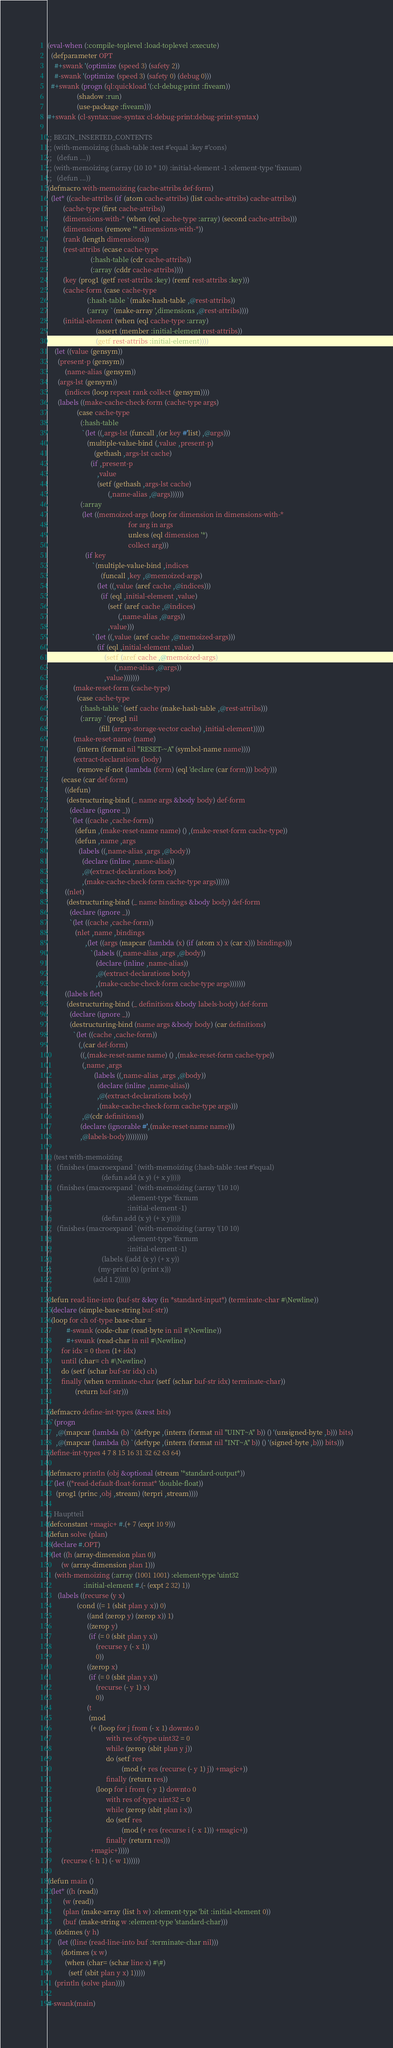<code> <loc_0><loc_0><loc_500><loc_500><_Lisp_>(eval-when (:compile-toplevel :load-toplevel :execute)
  (defparameter OPT
    #+swank '(optimize (speed 3) (safety 2))
    #-swank '(optimize (speed 3) (safety 0) (debug 0)))
  #+swank (progn (ql:quickload '(:cl-debug-print :fiveam))
                 (shadow :run)
                 (use-package :fiveam)))
#+swank (cl-syntax:use-syntax cl-debug-print:debug-print-syntax)

;; BEGIN_INSERTED_CONTENTS
;; (with-memoizing (:hash-table :test #'equal :key #'cons)
;;   (defun ...))
;; (with-memoizing (:array (10 10 * 10) :initial-element -1 :element-type 'fixnum)
;;   (defun ...))
(defmacro with-memoizing (cache-attribs def-form)
  (let* ((cache-attribs (if (atom cache-attribs) (list cache-attribs) cache-attribs))
         (cache-type (first cache-attribs))
         (dimensions-with-* (when (eql cache-type :array) (second cache-attribs)))
         (dimensions (remove '* dimensions-with-*))
         (rank (length dimensions))
         (rest-attribs (ecase cache-type
                         (:hash-table (cdr cache-attribs))
                         (:array (cddr cache-attribs))))
         (key (prog1 (getf rest-attribs :key) (remf rest-attribs :key)))
         (cache-form (case cache-type
                       (:hash-table `(make-hash-table ,@rest-attribs))
                       (:array `(make-array ',dimensions ,@rest-attribs))))
         (initial-element (when (eql cache-type :array)
                            (assert (member :initial-element rest-attribs))
                            (getf rest-attribs :initial-element))))
    (let ((value (gensym))
	  (present-p (gensym))
          (name-alias (gensym))
	  (args-lst (gensym))
          (indices (loop repeat rank collect (gensym))))
      (labels ((make-cache-check-form (cache-type args)
                 (case cache-type
                   (:hash-table
                    `(let ((,args-lst (funcall ,(or key #'list) ,@args)))
                       (multiple-value-bind (,value ,present-p)
                           (gethash ,args-lst cache)
                         (if ,present-p
                             ,value
                             (setf (gethash ,args-lst cache)
                                   (,name-alias ,@args))))))
                   (:array
                    (let ((memoized-args (loop for dimension in dimensions-with-*
                                               for arg in args
                                               unless (eql dimension '*)
                                               collect arg)))
                      (if key
                          `(multiple-value-bind ,indices
                               (funcall ,key ,@memoized-args)
                             (let ((,value (aref cache ,@indices)))
                               (if (eql ,initial-element ,value)
                                   (setf (aref cache ,@indices)
                                         (,name-alias ,@args))
                                   ,value)))
                          `(let ((,value (aref cache ,@memoized-args)))
                             (if (eql ,initial-element ,value)
                                 (setf (aref cache ,@memoized-args)
                                       (,name-alias ,@args))
                                 ,value)))))))
               (make-reset-form (cache-type)
                 (case cache-type
                   (:hash-table `(setf cache (make-hash-table ,@rest-attribs)))
                   (:array `(prog1 nil
                              (fill (array-storage-vector cache) ,initial-element)))))
               (make-reset-name (name)
                 (intern (format nil "RESET-~A" (symbol-name name))))
               (extract-declarations (body)
                 (remove-if-not (lambda (form) (eql 'declare (car form))) body)))
        (ecase (car def-form)
          ((defun)
           (destructuring-bind (_ name args &body body) def-form
             (declare (ignore _))
             `(let ((cache ,cache-form))
                (defun ,(make-reset-name name) () ,(make-reset-form cache-type))
                (defun ,name ,args
                  (labels ((,name-alias ,args ,@body))
                    (declare (inline ,name-alias))
                    ,@(extract-declarations body)
                    ,(make-cache-check-form cache-type args))))))
          ((nlet)
           (destructuring-bind (_ name bindings &body body) def-form
             (declare (ignore _))
             `(let ((cache ,cache-form))
                (nlet ,name ,bindings
                      ,(let ((args (mapcar (lambda (x) (if (atom x) x (car x))) bindings)))
                         `(labels ((,name-alias ,args ,@body))
                            (declare (inline ,name-alias))
                            ,@(extract-declarations body)
                            ,(make-cache-check-form cache-type args)))))))
          ((labels flet)
           (destructuring-bind (_ definitions &body labels-body) def-form
             (declare (ignore _))
             (destructuring-bind (name args &body body) (car definitions)
               `(let ((cache ,cache-form))
                  (,(car def-form)
                   ((,(make-reset-name name) () ,(make-reset-form cache-type))
                    (,name ,args
                           (labels ((,name-alias ,args ,@body))
                             (declare (inline ,name-alias))
                             ,@(extract-declarations body)
                             ,(make-cache-check-form cache-type args)))
                    ,@(cdr definitions))
                   (declare (ignorable #',(make-reset-name name)))
                   ,@labels-body))))))))))

;; (test with-memoizing
;;   (finishes (macroexpand `(with-memoizing (:hash-table :test #'equal)
;;                             (defun add (x y) (+ x y)))))
;;   (finishes (macroexpand `(with-memoizing (:array '(10 10)
;;                                            :element-type 'fixnum
;;                                            :initial-element -1)
;;                             (defun add (x y) (+ x y)))))
;;   (finishes (macroexpand `(with-memoizing (:array '(10 10)
;;                                            :element-type 'fixnum
;;                                            :initial-element -1)
;;                             (labels ((add (x y) (+ x y))
;; 		                     (my-print (x) (print x)))
;; 	                      (add 1 2))))))

(defun read-line-into (buf-str &key (in *standard-input*) (terminate-char #\Newline))
  (declare (simple-base-string buf-str))
  (loop for ch of-type base-char =
           #-swank (code-char (read-byte in nil #\Newline))
           #+swank (read-char in nil #\Newline)
        for idx = 0 then (1+ idx)
        until (char= ch #\Newline)
        do (setf (schar buf-str idx) ch)
        finally (when terminate-char (setf (schar buf-str idx) terminate-char))
                (return buf-str)))

(defmacro define-int-types (&rest bits)
  `(progn
     ,@(mapcar (lambda (b) `(deftype ,(intern (format nil "UINT~A" b)) () '(unsigned-byte ,b))) bits)
     ,@(mapcar (lambda (b) `(deftype ,(intern (format nil "INT~A" b)) () '(signed-byte ,b))) bits)))
(define-int-types 4 7 8 15 16 31 32 62 63 64)

(defmacro println (obj &optional (stream '*standard-output*))
  `(let ((*read-default-float-format* 'double-float))
     (prog1 (princ ,obj ,stream) (terpri ,stream))))

;; Hauptteil
(defconstant +magic+ #.(+ 7 (expt 10 9)))
(defun solve (plan)
  (declare #.OPT)
  (let ((h (array-dimension plan 0))
        (w (array-dimension plan 1)))
    (with-memoizing (:array (1001 1001) :element-type 'uint32
                     :initial-element #.(- (expt 2 32) 1))
      (labels ((recurse (y x)
                 (cond ((= 1 (sbit plan y x)) 0)
                       ((and (zerop y) (zerop x)) 1)
                       ((zerop y)
                        (if (= 0 (sbit plan y x))
                            (recurse y (- x 1))
                            0))
                       ((zerop x)
                        (if (= 0 (sbit plan y x))
                            (recurse (- y 1) x)
                            0))
                       (t
                        (mod
                         (+ (loop for j from (- x 1) downto 0
                                  with res of-type uint32 = 0
                                  while (zerop (sbit plan y j))
                                  do (setf res
                                           (mod (+ res (recurse (- y 1) j)) +magic+))
                                  finally (return res))
                            (loop for i from (- y 1) downto 0
                                  with res of-type uint32 = 0
                                  while (zerop (sbit plan i x))
                                  do (setf res
                                           (mod (+ res (recurse i (- x 1))) +magic+))
                                  finally (return res)))
                         +magic+)))))
        (recurse (- h 1) (- w 1))))))

(defun main ()
  (let* ((h (read))
         (w (read))
         (plan (make-array (list h w) :element-type 'bit :initial-element 0))
         (buf (make-string w :element-type 'standard-char)))
    (dotimes (y h)
      (let ((line (read-line-into buf :terminate-char nil)))
        (dotimes (x w)
          (when (char= (schar line x) #\#)
            (setf (sbit plan y x) 1)))))
    (println (solve plan))))

#-swank(main)
</code> 